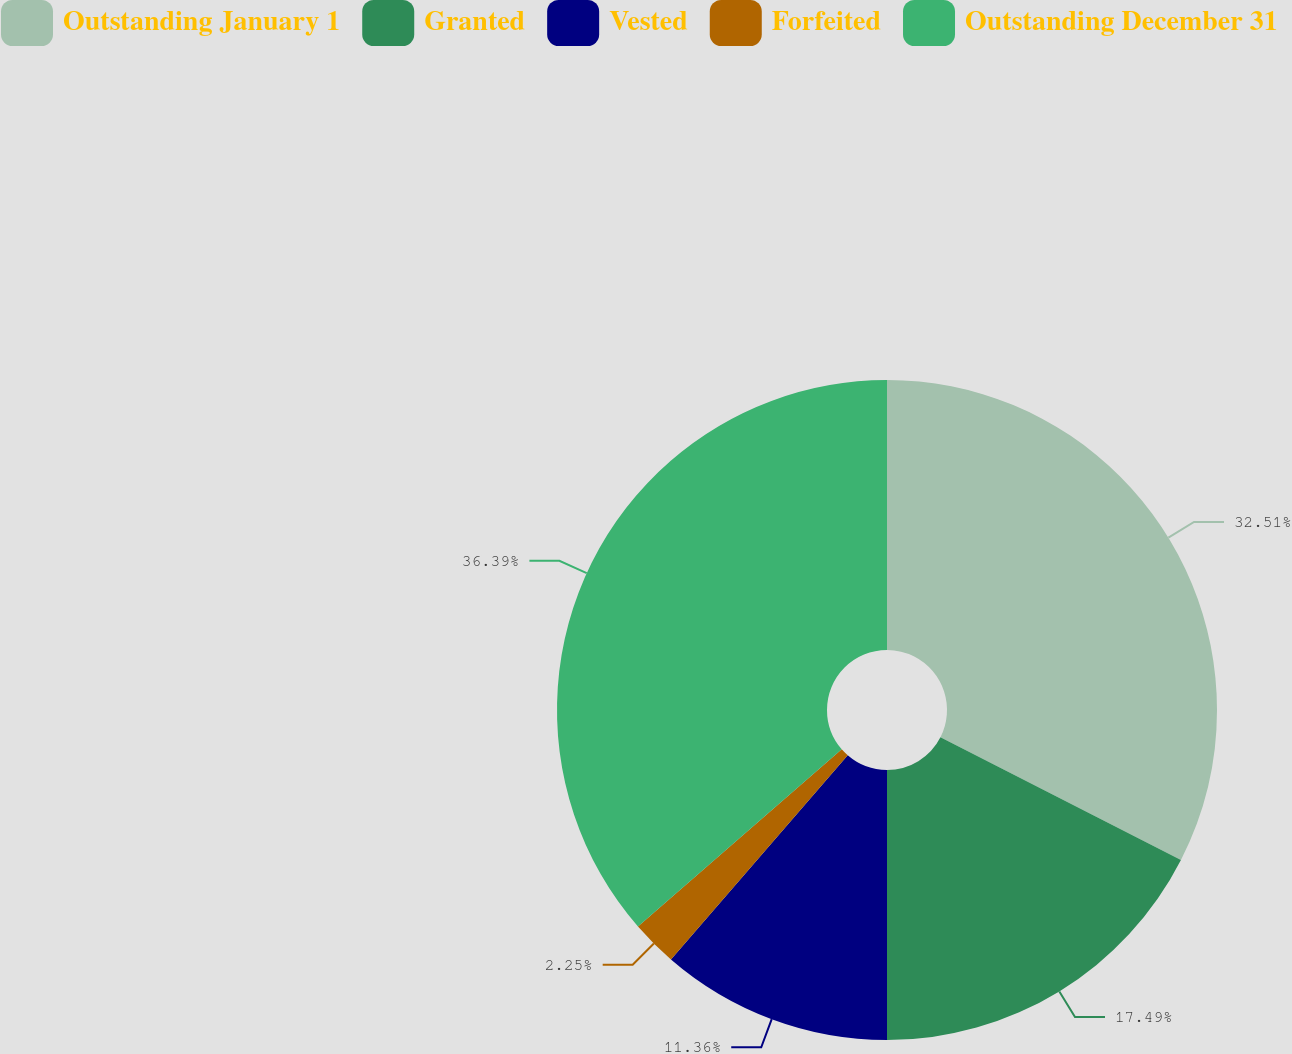Convert chart to OTSL. <chart><loc_0><loc_0><loc_500><loc_500><pie_chart><fcel>Outstanding January 1<fcel>Granted<fcel>Vested<fcel>Forfeited<fcel>Outstanding December 31<nl><fcel>32.51%<fcel>17.49%<fcel>11.36%<fcel>2.25%<fcel>36.39%<nl></chart> 